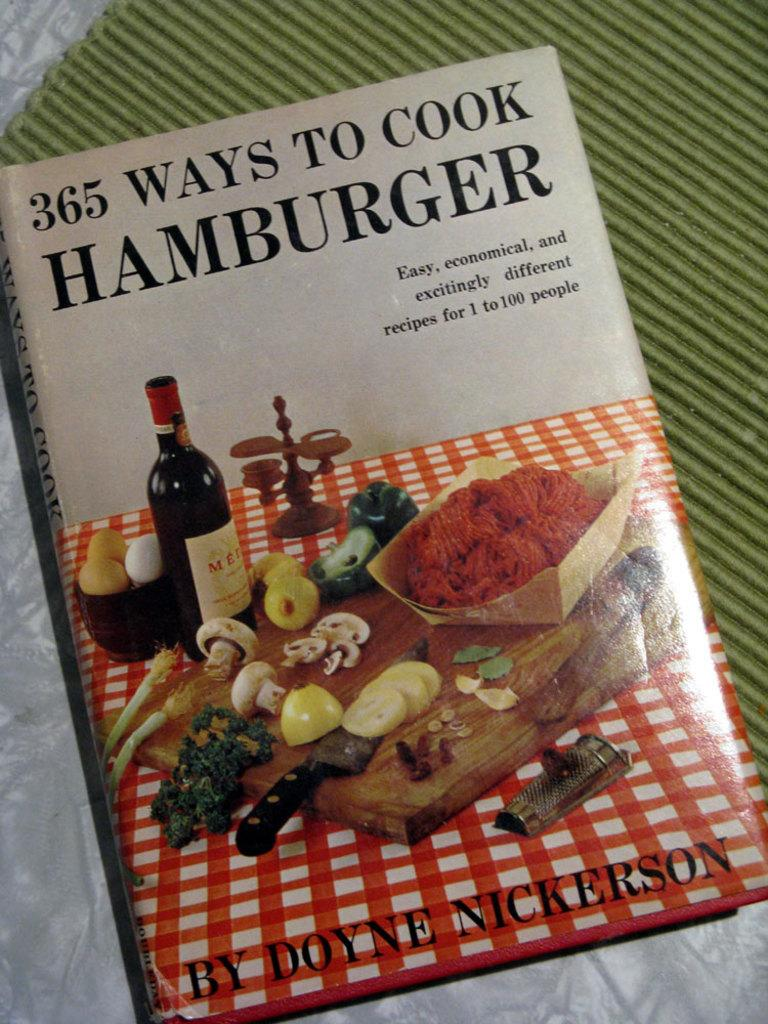<image>
Render a clear and concise summary of the photo. A cookbook called 365 Ways To Cook Hamburger is sitting on a counter. 